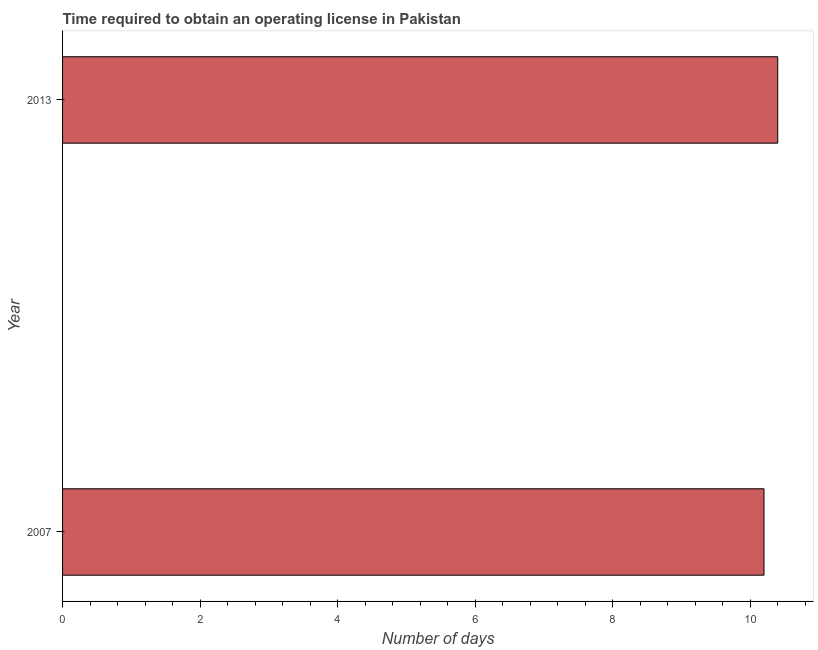Does the graph contain any zero values?
Your answer should be very brief. No. Does the graph contain grids?
Your answer should be compact. No. What is the title of the graph?
Give a very brief answer. Time required to obtain an operating license in Pakistan. What is the label or title of the X-axis?
Provide a short and direct response. Number of days. What is the label or title of the Y-axis?
Provide a succinct answer. Year. Across all years, what is the minimum number of days to obtain operating license?
Offer a terse response. 10.2. In which year was the number of days to obtain operating license minimum?
Offer a very short reply. 2007. What is the sum of the number of days to obtain operating license?
Keep it short and to the point. 20.6. Do a majority of the years between 2007 and 2013 (inclusive) have number of days to obtain operating license greater than 2 days?
Offer a terse response. Yes. What is the ratio of the number of days to obtain operating license in 2007 to that in 2013?
Make the answer very short. 0.98. In how many years, is the number of days to obtain operating license greater than the average number of days to obtain operating license taken over all years?
Keep it short and to the point. 1. Are all the bars in the graph horizontal?
Ensure brevity in your answer.  Yes. How many years are there in the graph?
Provide a short and direct response. 2. What is the difference between two consecutive major ticks on the X-axis?
Ensure brevity in your answer.  2. What is the Number of days of 2007?
Your answer should be very brief. 10.2. What is the Number of days of 2013?
Provide a succinct answer. 10.4. What is the difference between the Number of days in 2007 and 2013?
Provide a succinct answer. -0.2. 